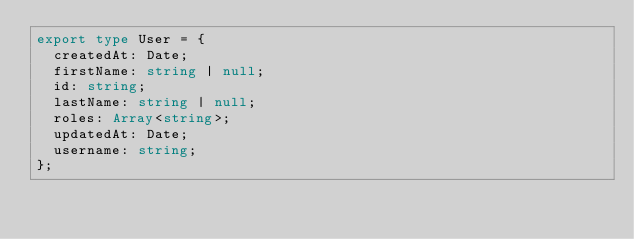<code> <loc_0><loc_0><loc_500><loc_500><_TypeScript_>export type User = {
  createdAt: Date;
  firstName: string | null;
  id: string;
  lastName: string | null;
  roles: Array<string>;
  updatedAt: Date;
  username: string;
};
</code> 